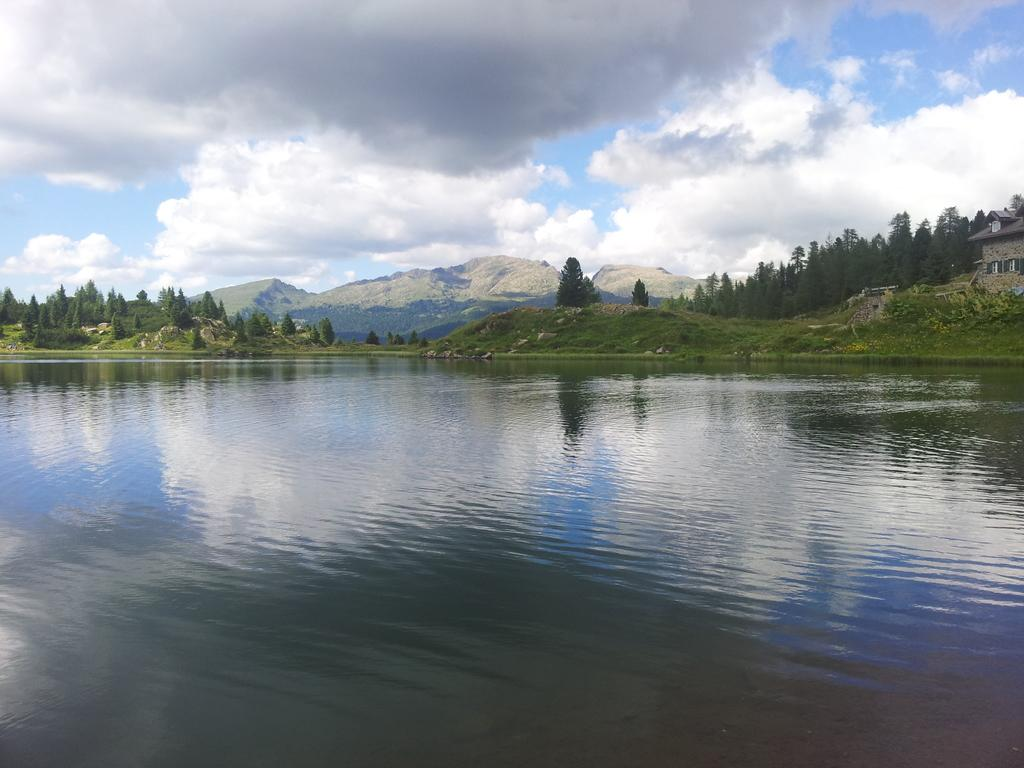What is the primary element visible in the image? There is water in the image. What type of terrain can be seen on the hills in the image? There is a grass surface on the hills in the image. What other objects can be seen in the image? There are rocks, trees, and hills visible in the image. What is visible in the background of the image? The sky is visible in the image, and clouds are present in the sky. How many dogs are sitting on the cobweb in the image? There are no dogs or cobwebs present in the image. What type of comb is being used to groom the trees in the image? There is no comb or grooming activity involving trees in the image. 